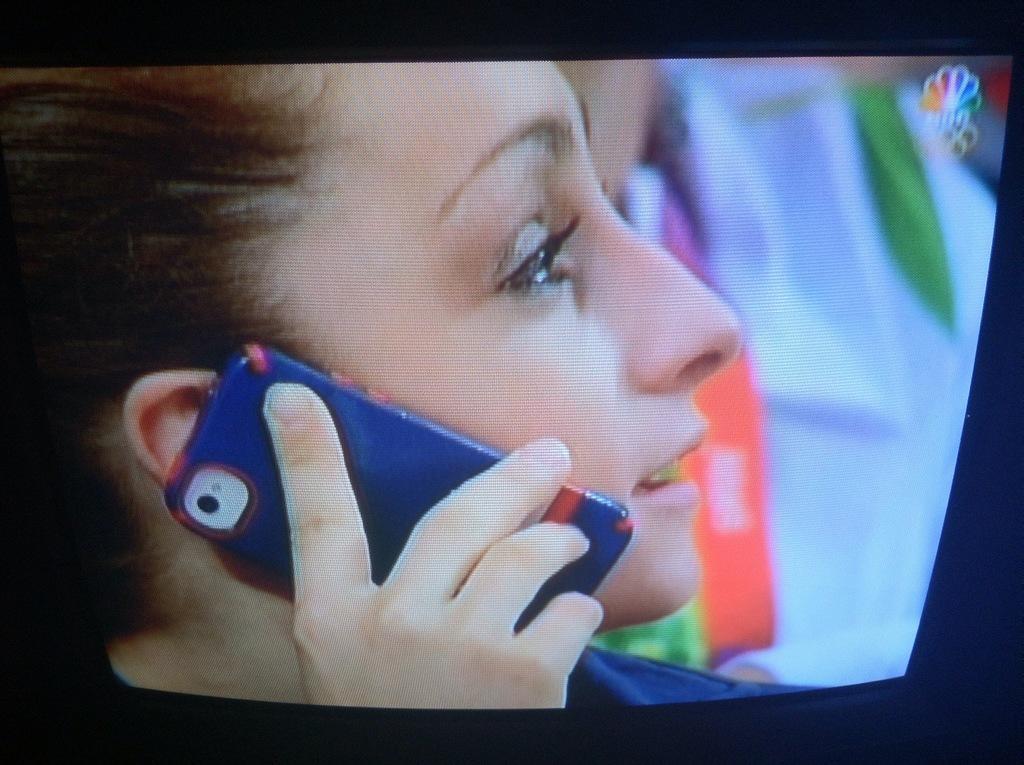Can you describe this image briefly? In the center of the image a screen is there. On screen we can see a person is holding a mobile. 